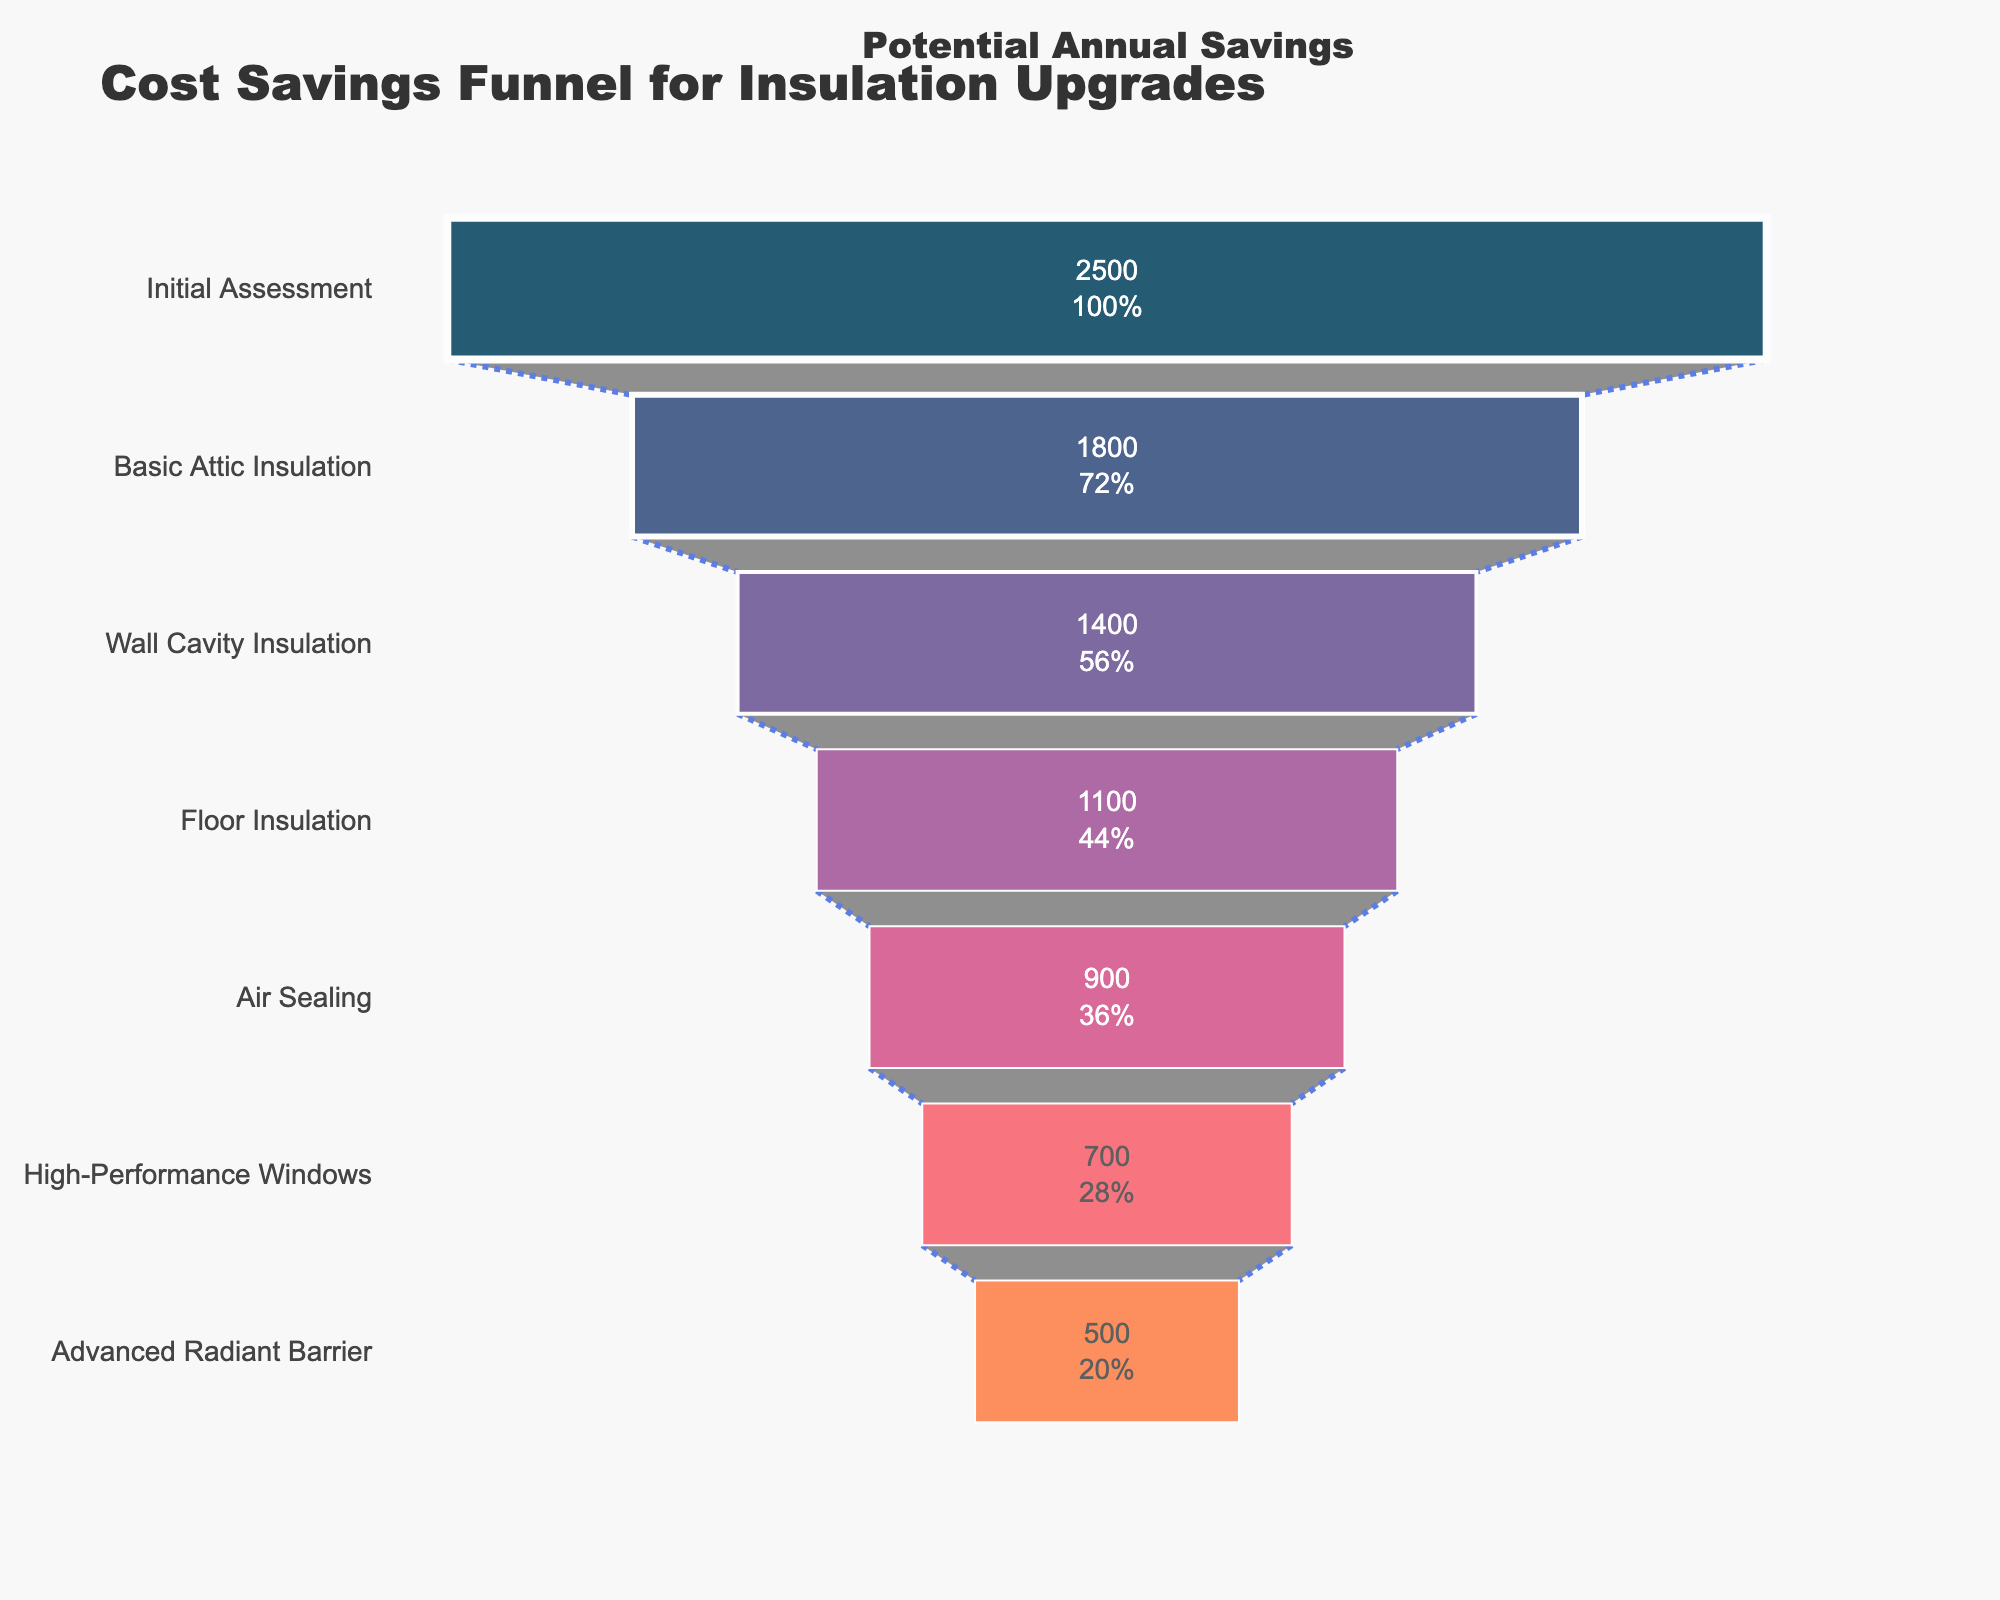How many stages are represented in the funnel chart? Count the distinct stages listed in the funnel chart. There are 7 stages in total: "Initial Assessment," "Basic Attic Insulation," "Wall Cavity Insulation," "Floor Insulation," "Air Sealing," "High-Performance Windows," and "Advanced Radiant Barrier."
Answer: 7 Which stage provides the highest annual cost savings? Identify the stage with the largest value in the funnel chart. "Initial Assessment" has the highest annual cost savings of $2500.
Answer: Initial Assessment What's the total annual cost savings when performing Basic Attic Insulation, Wall Cavity Insulation, and Floor Insulation together? Sum the annual savings for "Basic Attic Insulation" ($1800), "Wall Cavity Insulation" ($1400), and "Floor Insulation" ($1100). The total is 1800 + 1400 + 1100 = 4300.
Answer: 4300 How much more annual cost savings does "Initial Assessment" provide compared to "Advanced Radiant Barrier"? Subtract the annual cost savings of "Advanced Radiant Barrier" ($500) from "Initial Assessment" ($2500). The difference is 2500 - 500 = 2000.
Answer: 2000 What percentage of the initial savings is retained after "Air Sealing"? Compare the annual cost savings from "Air Sealing" ($900) to the "Initial Assessment" ($2500) and compute the percentage. The percentage is (900 / 2500) * 100 = 36%.
Answer: 36% Which stage offers the least reduction in annual cost savings as compared to the stage just before it? Calculate the reduction in annual cost savings for each stage compared to the one before it and find the smallest reduction. "Advanced Radiant Barrier" reduces by $200 from "High-Performance Windows," which is the least reduction.
Answer: Advanced Radiant Barrier If you perform all the insulation upgrades listed, what would be the total cost savings? Sum up the annual cost savings for each stage. The total savings are 2500 + 1800 + 1400 + 1100 + 900 + 700 + 500 = 8900.
Answer: 8900 Does "Floor Insulation" provide more annual cost savings than "Air Sealing" and "High-Performance Windows" combined? Compare the annual cost savings of "Floor Insulation" ($1100) to the sum of "Air Sealing" ($900) and "High-Performance Windows" ($700). The combined savings of Air Sealing and High-Performance Windows are 900 + 700 = 1600, which is more than "Floor Insulation" ($1100).
Answer: No What stage marks the halfway point in terms of cumulative annual cost savings? Sum the annual savings until reaching half the total savings. The total savings are 8900, so halfway is 4450. Initial Assessment ($2500) + Basic Attic Insulation ($1800) = $4300. The next stage, Wall Cavity Insulation ($1400), reaches more than half, hence between "Basic Attic Insulation" and "Wall Cavity Insulation".
Answer: Between Basic Attic Insulation and Wall Cavity Insulation 